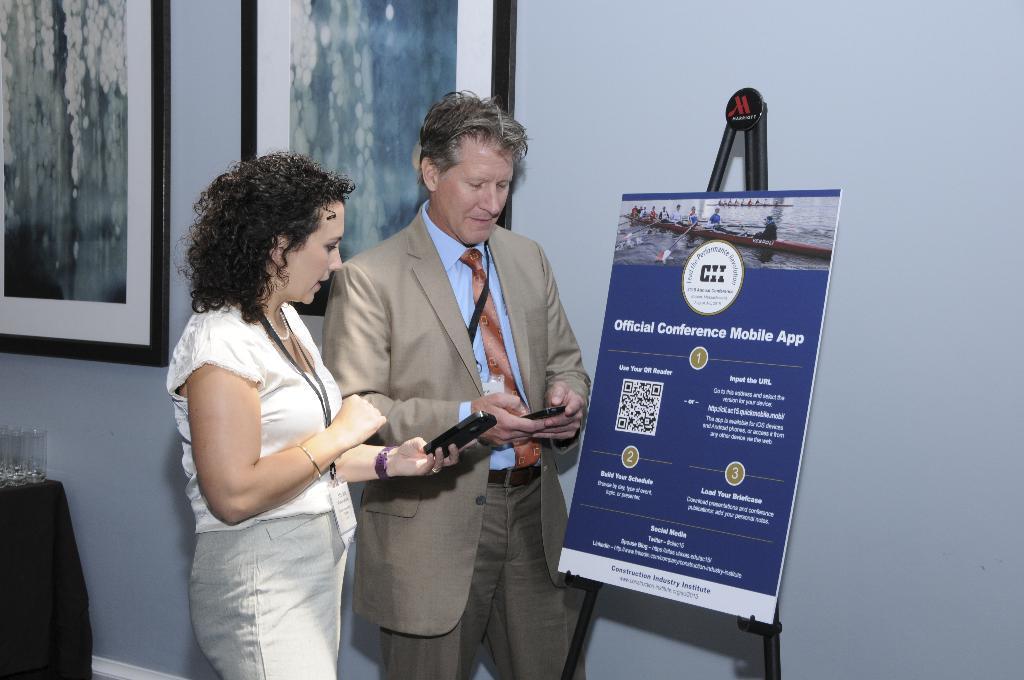Could you give a brief overview of what you see in this image? In this image I can see two people standing in-front of the board. These people are wearing the different color dresses and holding the mobiles. The board is in blue color and something is written on it. In the back I can see frames to the wall. To the left there are glasses on the table. 